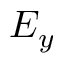Convert formula to latex. <formula><loc_0><loc_0><loc_500><loc_500>E _ { y }</formula> 